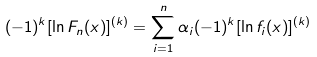Convert formula to latex. <formula><loc_0><loc_0><loc_500><loc_500>( - 1 ) ^ { k } [ \ln F _ { n } ( x ) ] ^ { ( k ) } = \sum _ { i = 1 } ^ { n } \alpha _ { i } ( - 1 ) ^ { k } [ \ln f _ { i } ( x ) ] ^ { ( k ) }</formula> 